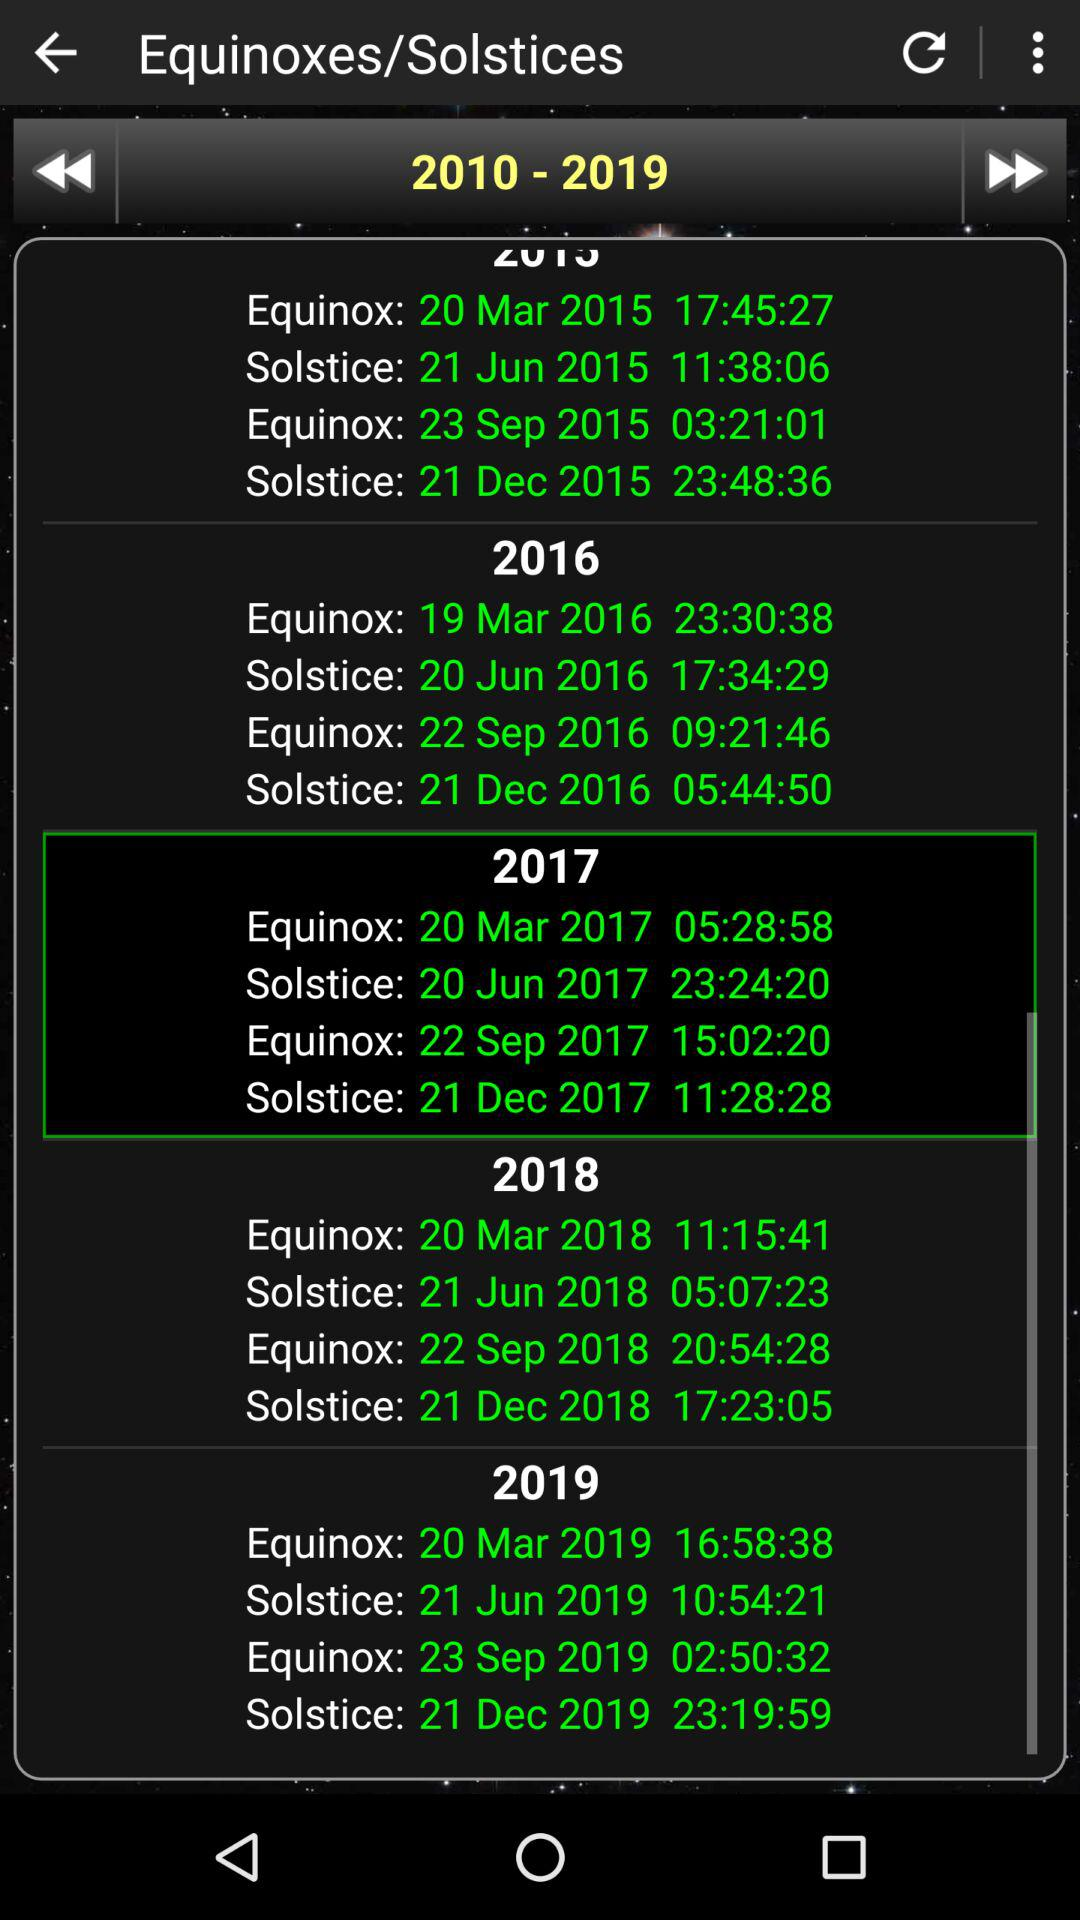Which date and time were selected for the solstices?
When the provided information is insufficient, respond with <no answer>. <no answer> 